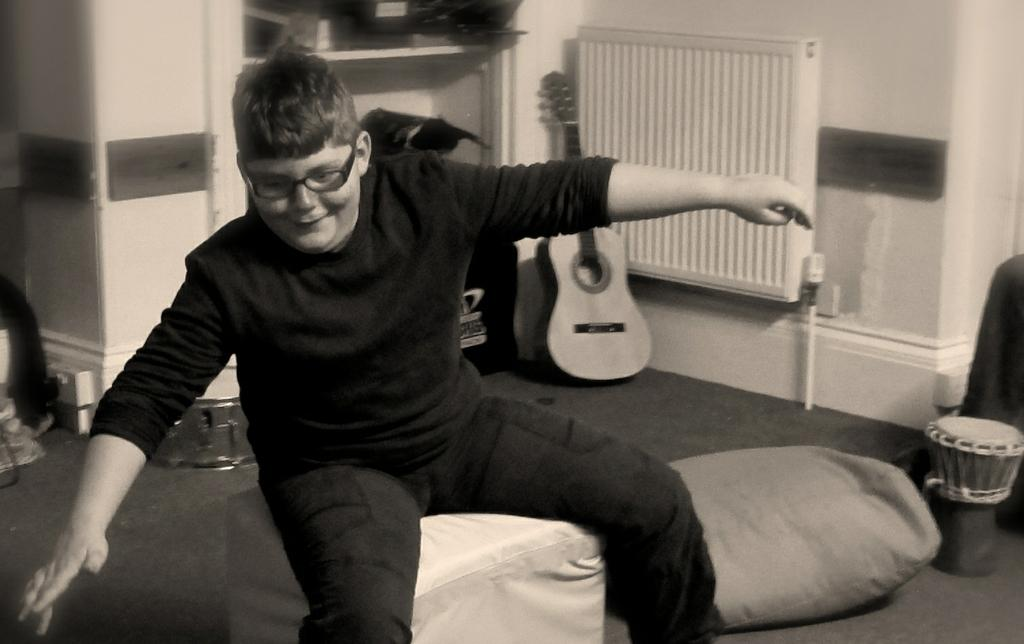What is the boy doing in the image? The boy is sitting on the couch in the image. Can you describe the boy's appearance? The boy is wearing glasses. What musical instruments are present in the image? There is a guitar and a drum in the image. What is the boy's belief about the yak in the image? There is no yak present in the image, so it is not possible to determine the boy's belief about a yak. 